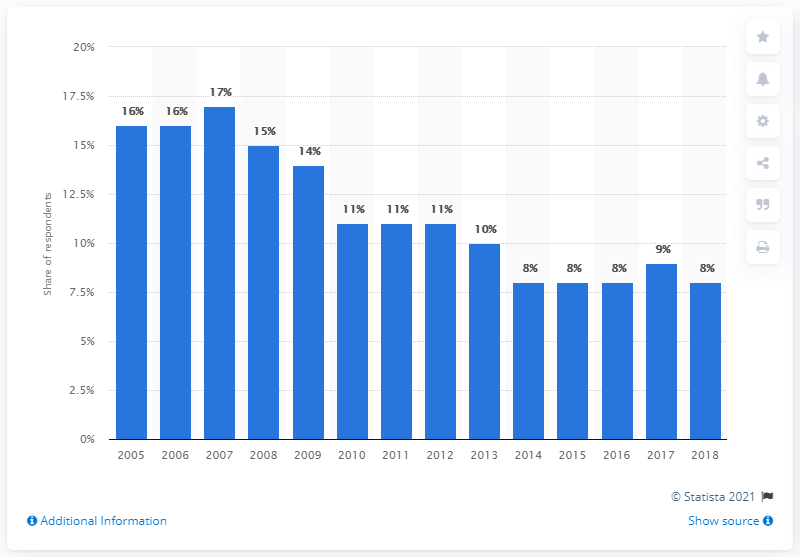Highlight a few significant elements in this photo. According to a survey conducted from 2005 to 2018, a significant percentage of people reported that vandalism, graffiti, or damage to property was common in their area. 